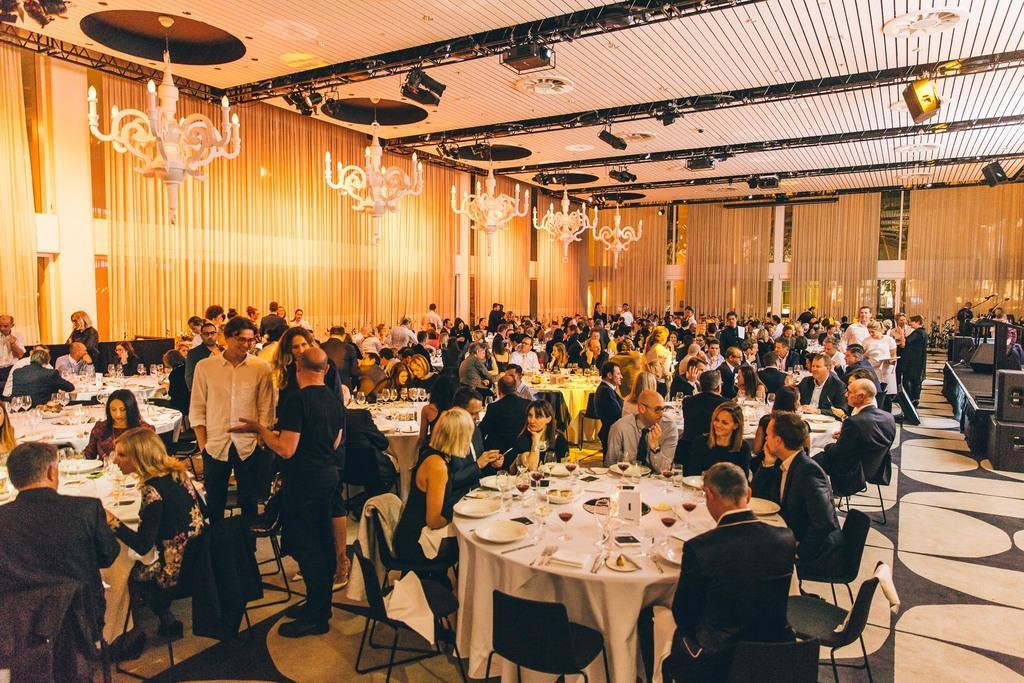Describe this image in one or two sentences. This picture is clicked inside restaurant. Here, we see many people sitting on chairs and and also we see many tables on which plate, spoon, glass, fork, microphone are placed on it and on background, we see a wall and curtains which are yellow in color. 